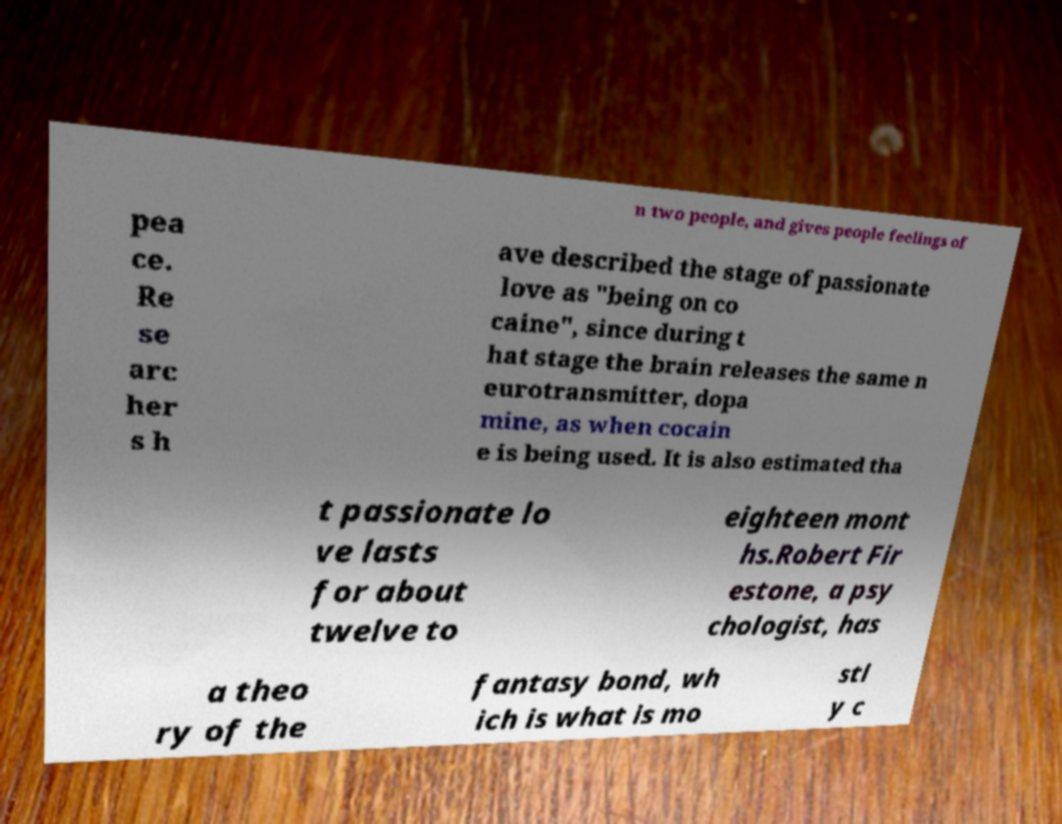For documentation purposes, I need the text within this image transcribed. Could you provide that? n two people, and gives people feelings of pea ce. Re se arc her s h ave described the stage of passionate love as "being on co caine", since during t hat stage the brain releases the same n eurotransmitter, dopa mine, as when cocain e is being used. It is also estimated tha t passionate lo ve lasts for about twelve to eighteen mont hs.Robert Fir estone, a psy chologist, has a theo ry of the fantasy bond, wh ich is what is mo stl y c 